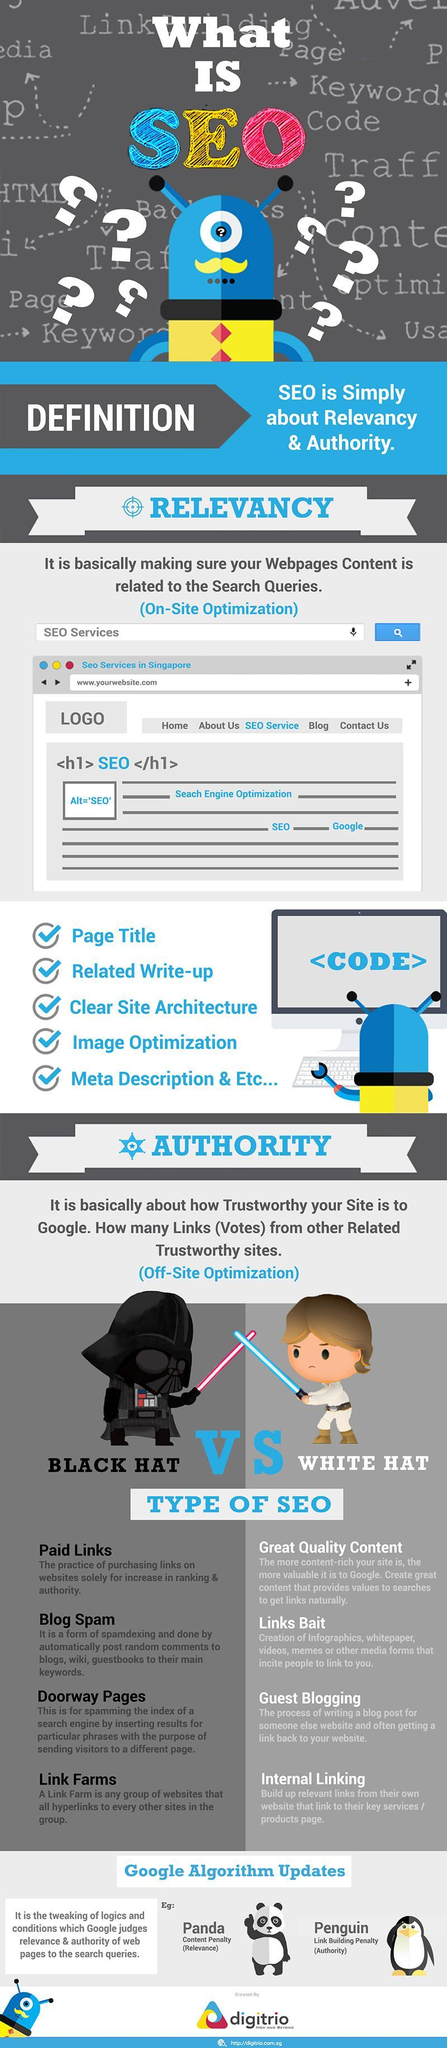what is the third check point in relevancy
Answer the question with a short phrase. clear site architecture guest blogging is which type of SEO white hat what is used for spamming the index of a search engine doorway pages what is the colour of the sword held by the black figure, red or blue red how many types of SEO are there 2 